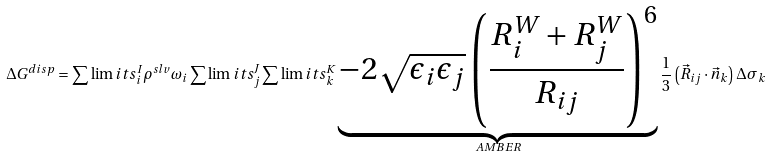<formula> <loc_0><loc_0><loc_500><loc_500>\Delta G ^ { d i s p } = \sum \lim i t s _ { i } ^ { I } \rho ^ { s l v } \omega _ { i } \sum \lim i t s _ { j } ^ { J } \sum \lim i t s _ { k } ^ { K } \underbrace { - 2 \sqrt { \epsilon _ { i } \epsilon _ { j } } \left ( \frac { R _ { i } ^ { W } + R _ { j } ^ { W } } { R _ { i j } } \right ) ^ { 6 } } _ { A M B E R } \frac { 1 } { 3 } \left ( \vec { R } _ { i j } \cdot \vec { n } _ { k } \right ) \Delta \sigma _ { k }</formula> 